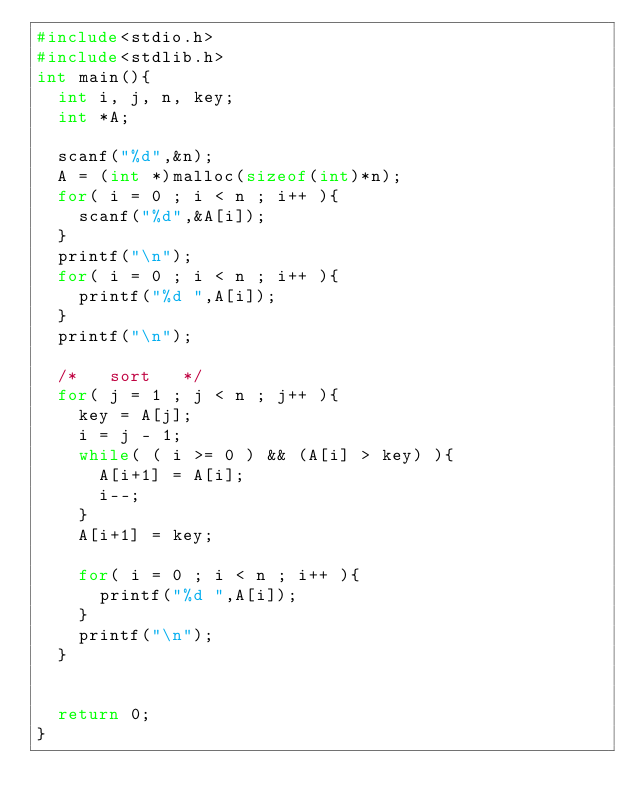Convert code to text. <code><loc_0><loc_0><loc_500><loc_500><_C_>#include<stdio.h>
#include<stdlib.h>
int main(){
  int i, j, n, key;
  int *A;

  scanf("%d",&n);
  A = (int *)malloc(sizeof(int)*n);
  for( i = 0 ; i < n ; i++ ){
    scanf("%d",&A[i]);
  }
  printf("\n");
  for( i = 0 ; i < n ; i++ ){
    printf("%d ",A[i]);
  }
  printf("\n");

  /*   sort   */
  for( j = 1 ; j < n ; j++ ){
    key = A[j];
    i = j - 1;
    while( ( i >= 0 ) && (A[i] > key) ){
      A[i+1] = A[i];
      i--;
    }
    A[i+1] = key;
    
    for( i = 0 ; i < n ; i++ ){
      printf("%d ",A[i]);
    }
    printf("\n");
  }

  
  return 0;
}

</code> 